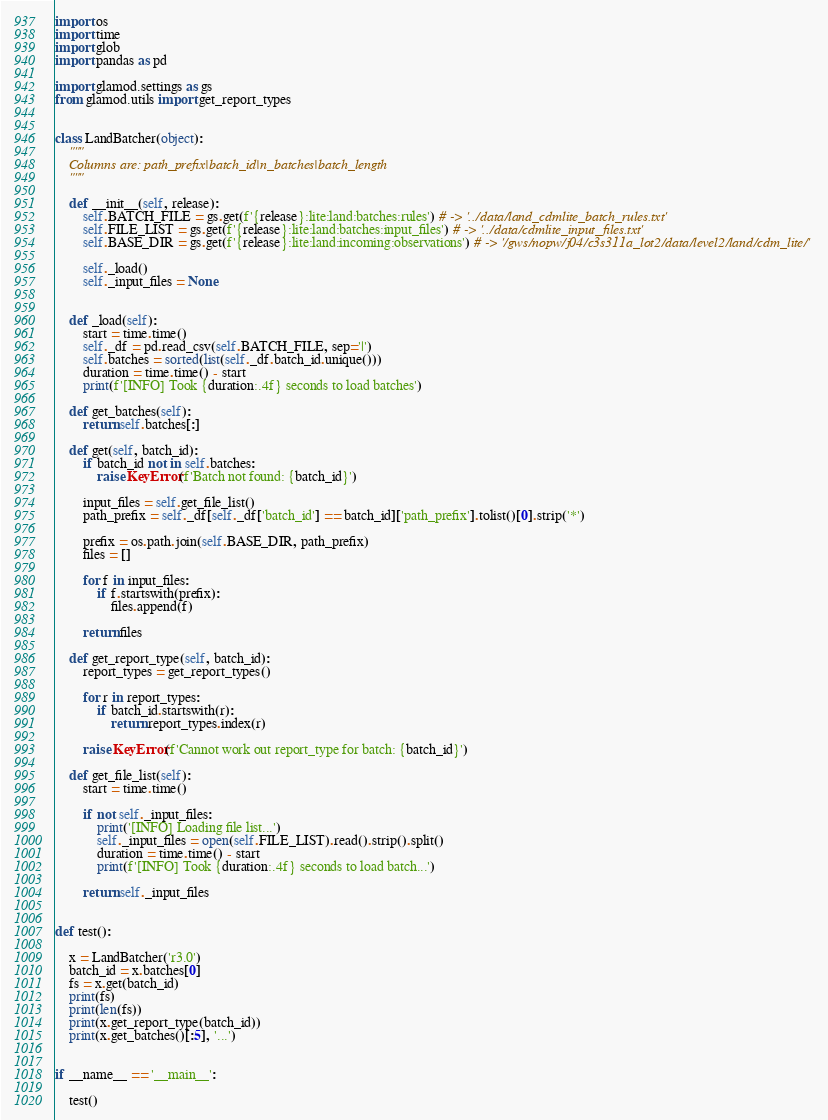Convert code to text. <code><loc_0><loc_0><loc_500><loc_500><_Python_>import os
import time
import glob
import pandas as pd

import glamod.settings as gs
from glamod.utils import get_report_types


class LandBatcher(object):
    """
    Columns are: path_prefix|batch_id|n_batches|batch_length
    """

    def __init__(self, release):
        self.BATCH_FILE = gs.get(f'{release}:lite:land:batches:rules') # -> '../data/land_cdmlite_batch_rules.txt'
        self.FILE_LIST = gs.get(f'{release}:lite:land:batches:input_files') # -> '../data/cdmlite_input_files.txt'
        self.BASE_DIR = gs.get(f'{release}:lite:land:incoming:observations') # -> '/gws/nopw/j04/c3s311a_lot2/data/level2/land/cdm_lite/'
        
        self._load()
        self._input_files = None


    def _load(self):
        start = time.time()
        self._df = pd.read_csv(self.BATCH_FILE, sep='|')
        self.batches = sorted(list(self._df.batch_id.unique()))
        duration = time.time() - start
        print(f'[INFO] Took {duration:.4f} seconds to load batches')

    def get_batches(self):
        return self.batches[:]

    def get(self, batch_id):
        if batch_id not in self.batches:
            raise KeyError(f'Batch not found: {batch_id}')

        input_files = self.get_file_list()
        path_prefix = self._df[self._df['batch_id'] == batch_id]['path_prefix'].tolist()[0].strip('*')

        prefix = os.path.join(self.BASE_DIR, path_prefix)
        files = []

        for f in input_files:
            if f.startswith(prefix):
                files.append(f)

        return files

    def get_report_type(self, batch_id):
        report_types = get_report_types()

        for r in report_types:
            if batch_id.startswith(r):
                return report_types.index(r)

        raise KeyError(f'Cannot work out report_type for batch: {batch_id}')

    def get_file_list(self):
        start = time.time()

        if not self._input_files:
            print('[INFO] Loading file list...')
            self._input_files = open(self.FILE_LIST).read().strip().split()
            duration = time.time() - start
            print(f'[INFO] Took {duration:.4f} seconds to load batch...')

        return self._input_files


def test():

    x = LandBatcher('r3.0')
    batch_id = x.batches[0]
    fs = x.get(batch_id)
    print(fs)
    print(len(fs))
    print(x.get_report_type(batch_id))
    print(x.get_batches()[:5], '...')


if __name__ == '__main__':

    test() 
</code> 